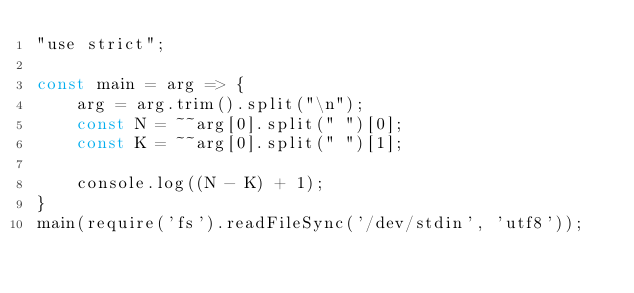Convert code to text. <code><loc_0><loc_0><loc_500><loc_500><_JavaScript_>"use strict";
    
const main = arg => {
    arg = arg.trim().split("\n");
    const N = ~~arg[0].split(" ")[0];
    const K = ~~arg[0].split(" ")[1];
    
    console.log((N - K) + 1);
}
main(require('fs').readFileSync('/dev/stdin', 'utf8'));</code> 